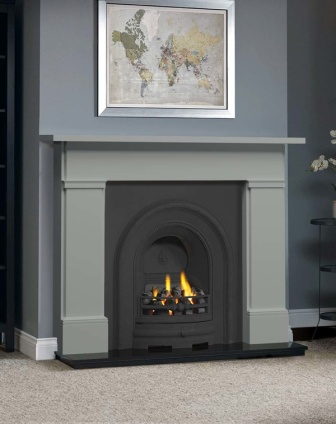What might be the historical significance of the painting above the fireplace? The painting above the fireplace, displaying a world map, suggests a theme of travel or a global perspective. Historically, such art pieces were often used to reflect the interests or aspirations of the homeowners, possibly hinting at an affinity for geography, history, or exploration. This choice of art could serve as a conversation starter or a reflection of personal or intellectual curiosity about different cultures and world regions. 